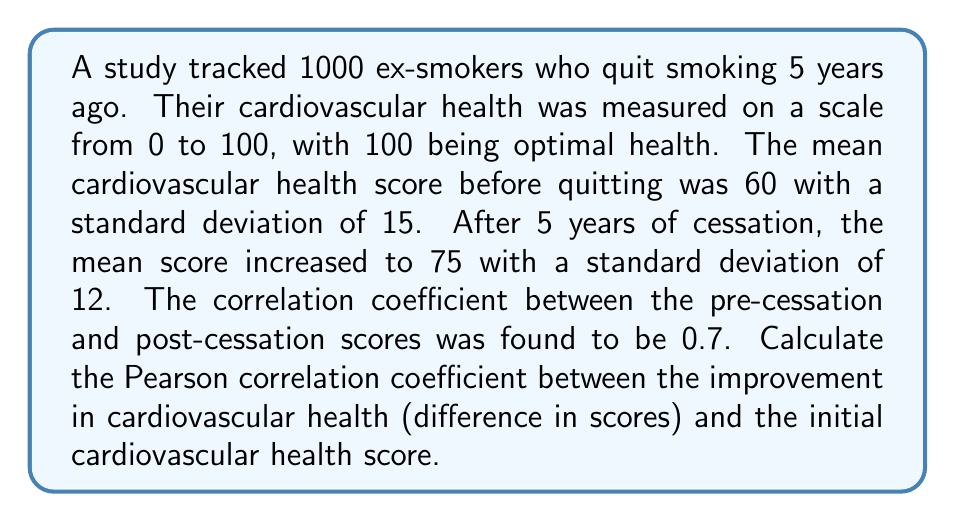Could you help me with this problem? Let's approach this step-by-step:

1) Let X be the initial health score and Y be the final health score.
   We're interested in the correlation between X and (Y-X).

2) We're given:
   $\mu_X = 60$, $\sigma_X = 15$
   $\mu_Y = 75$, $\sigma_Y = 12$
   $\rho_{XY} = 0.7$

3) The correlation coefficient we're looking for is:

   $$\rho_{X,(Y-X)} = \frac{Cov(X,Y-X)}{\sigma_X \sigma_{Y-X}}$$

4) First, let's calculate $Cov(X,Y-X)$:
   
   $Cov(X,Y-X) = Cov(X,Y) - Cov(X,X) = \rho_{XY}\sigma_X\sigma_Y - \sigma_X^2$
   
   $= 0.7 \cdot 15 \cdot 12 - 15^2 = 126 - 225 = -99$

5) Next, we need $\sigma_{Y-X}$. We can calculate this using:

   $\sigma_{Y-X}^2 = \sigma_Y^2 + \sigma_X^2 - 2\rho_{XY}\sigma_X\sigma_Y$
   
   $= 12^2 + 15^2 - 2 \cdot 0.7 \cdot 12 \cdot 15$
   
   $= 144 + 225 - 252 = 117$

   So, $\sigma_{Y-X} = \sqrt{117} \approx 10.82$

6) Now we can calculate the correlation coefficient:

   $$\rho_{X,(Y-X)} = \frac{-99}{15 \cdot 10.82} \approx -0.61$$
Answer: $-0.61$ 